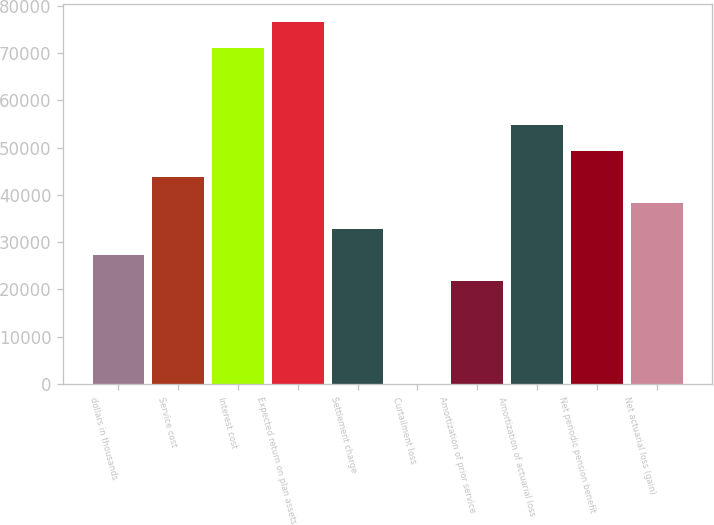Convert chart to OTSL. <chart><loc_0><loc_0><loc_500><loc_500><bar_chart><fcel>dollars in thousands<fcel>Service cost<fcel>Interest cost<fcel>Expected return on plan assets<fcel>Settlement charge<fcel>Curtailment loss<fcel>Amortization of prior service<fcel>Amortization of actuarial loss<fcel>Net periodic pension benefit<fcel>Net actuarial loss (gain)<nl><fcel>27369<fcel>43789.2<fcel>71156.2<fcel>76629.6<fcel>32842.4<fcel>1.98<fcel>21895.6<fcel>54736<fcel>49262.6<fcel>38315.8<nl></chart> 